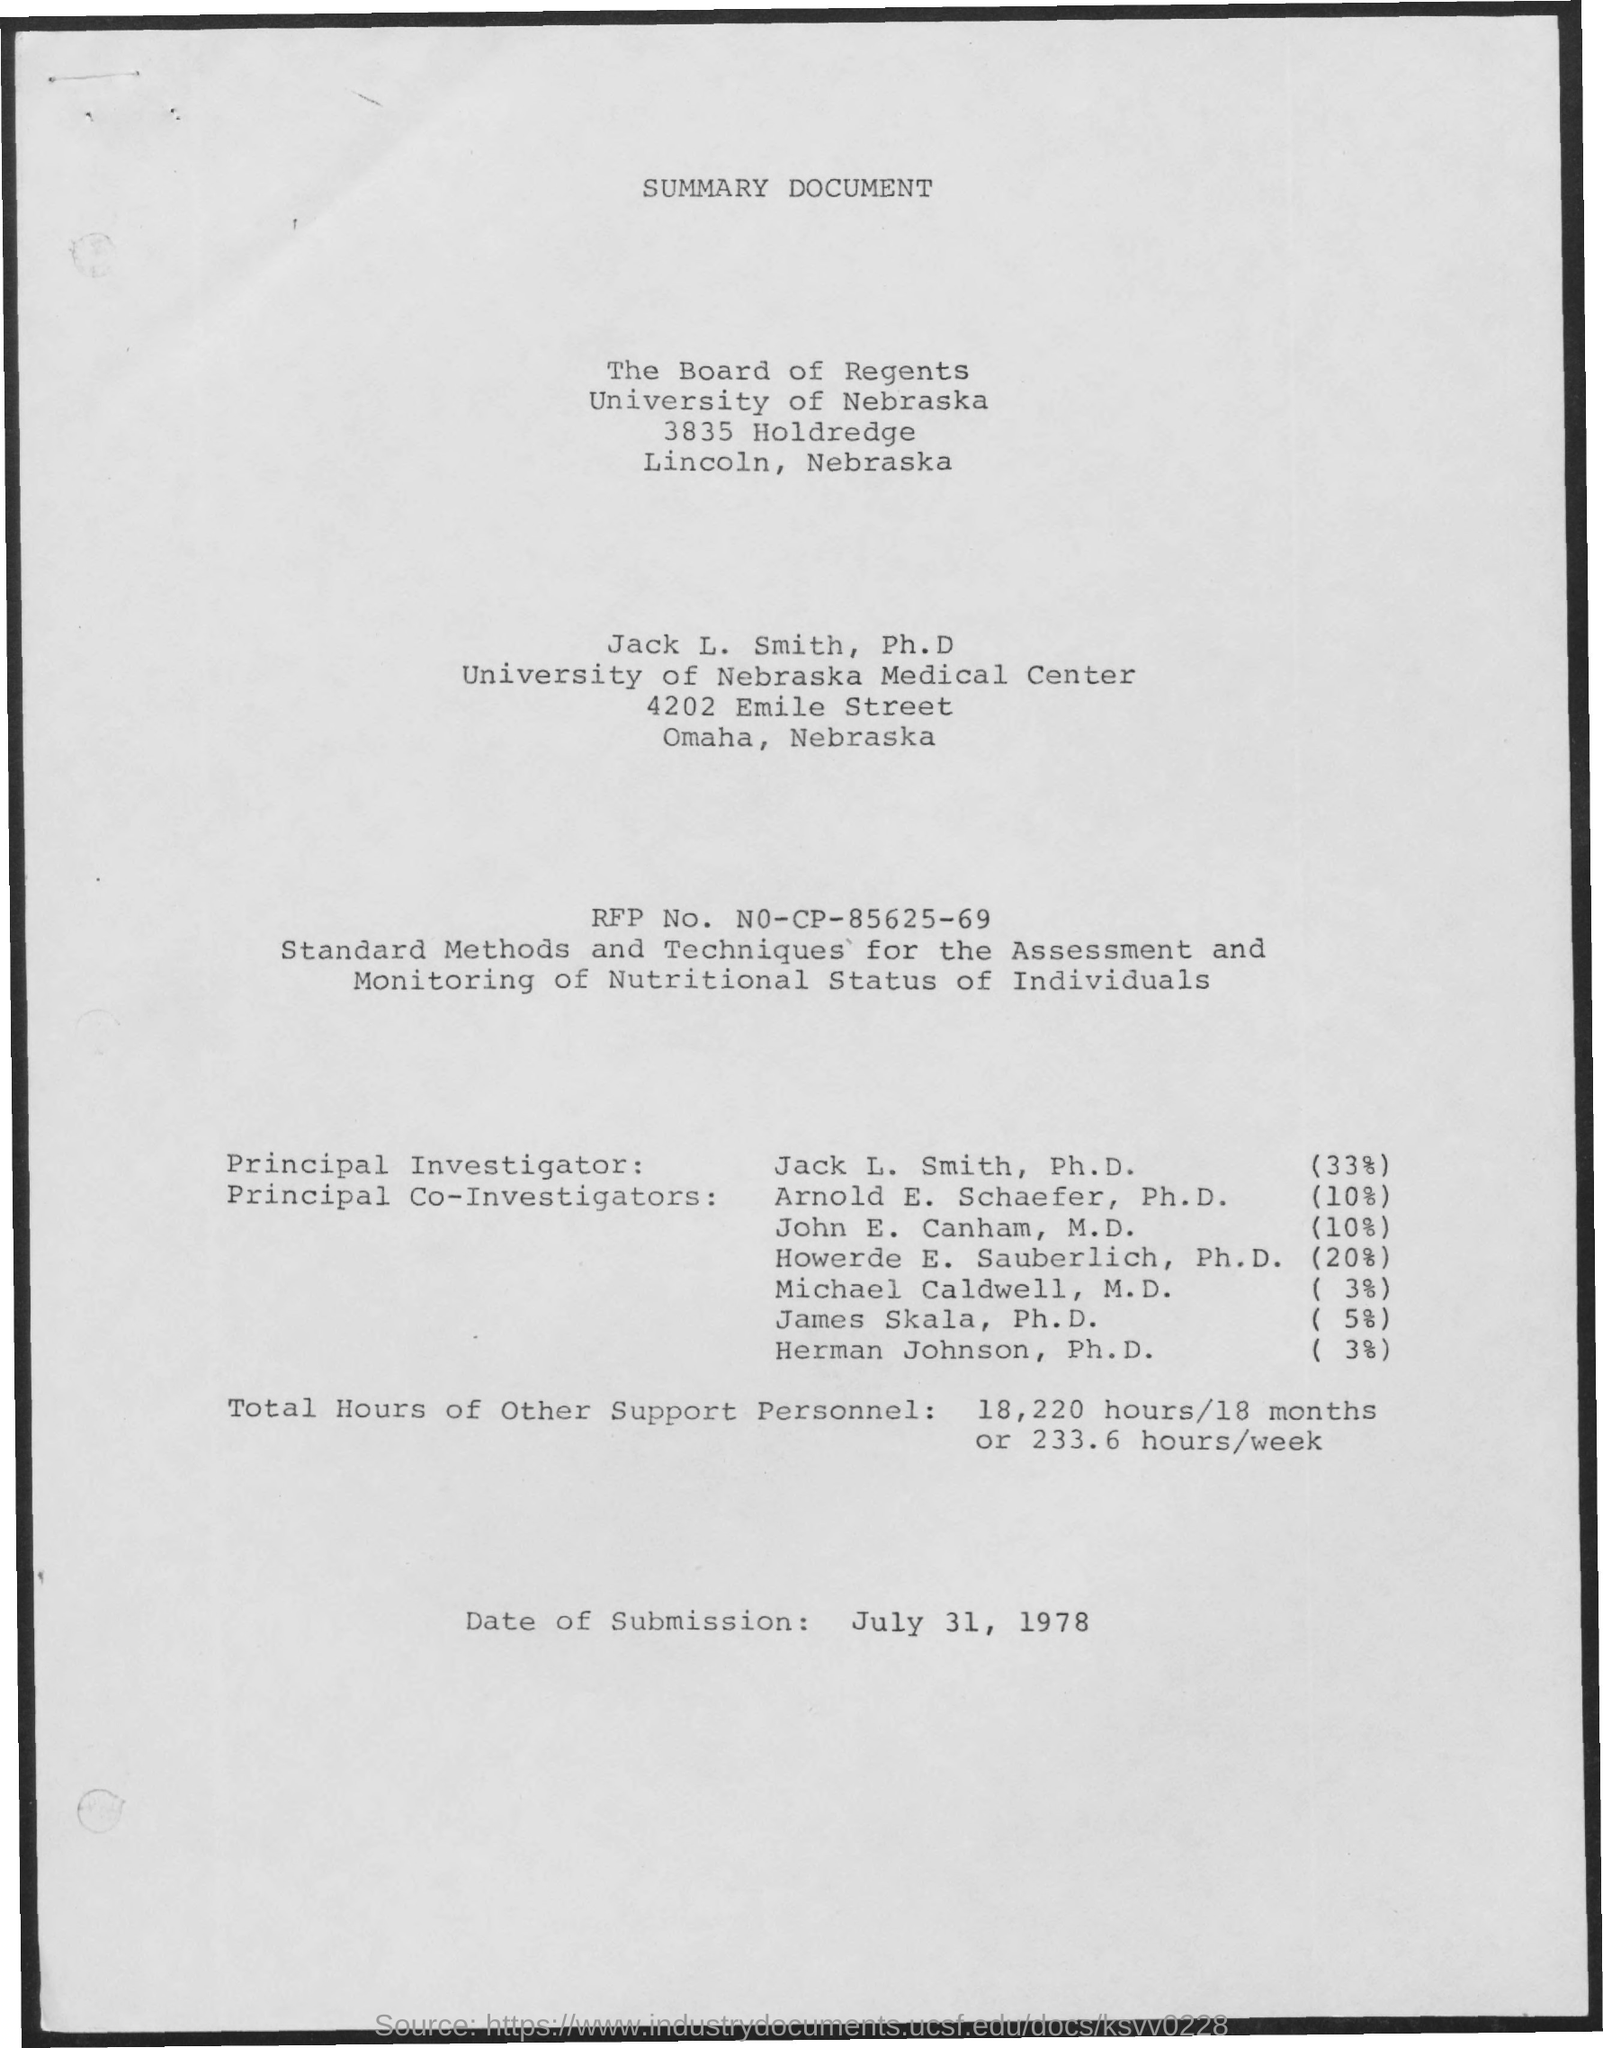Mention a couple of crucial points in this snapshot. The RFP number is N0-CP-85625-69. The document is titled "SUMMARY DOCUMENT. The principal investigator is JACK L. SMITH, PH.D. The date of submission is July 31, 1978. In total, 18,220 hours of support personnel were provided over the course of 18 months, resulting in an average of 233.6 hours per week. 